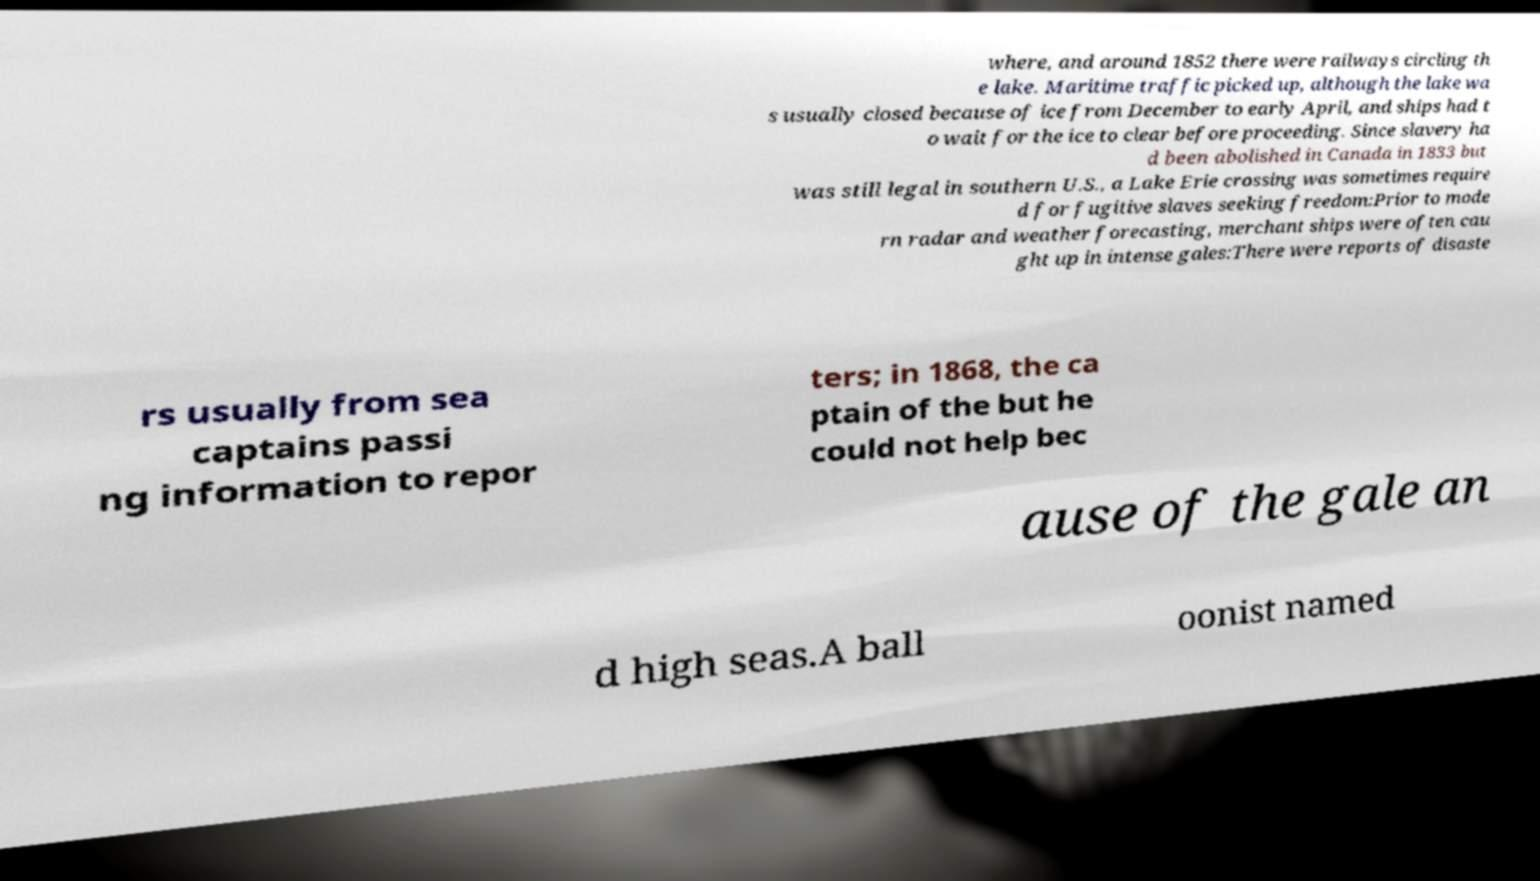Please identify and transcribe the text found in this image. where, and around 1852 there were railways circling th e lake. Maritime traffic picked up, although the lake wa s usually closed because of ice from December to early April, and ships had t o wait for the ice to clear before proceeding. Since slavery ha d been abolished in Canada in 1833 but was still legal in southern U.S., a Lake Erie crossing was sometimes require d for fugitive slaves seeking freedom:Prior to mode rn radar and weather forecasting, merchant ships were often cau ght up in intense gales:There were reports of disaste rs usually from sea captains passi ng information to repor ters; in 1868, the ca ptain of the but he could not help bec ause of the gale an d high seas.A ball oonist named 